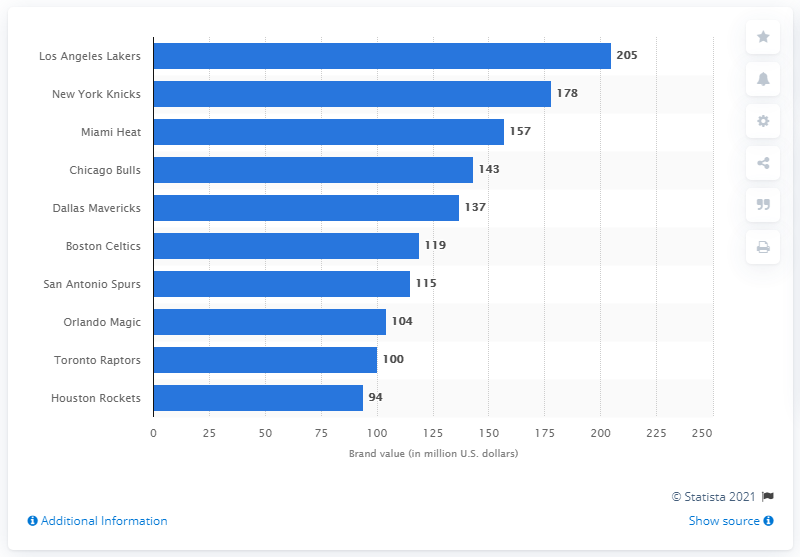Draw attention to some important aspects in this diagram. In 2012, the brand value of the Los Angeles Lakers in the National Basketball Association (NBA) was 205 million dollars, making them one of the most valuable teams in the league. In 2012, the Los Angeles Lakers had a brand value of 205. 